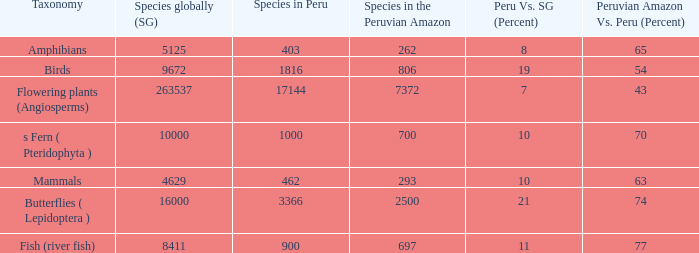Could you parse the entire table as a dict? {'header': ['Taxonomy', 'Species globally (SG)', 'Species in Peru', 'Species in the Peruvian Amazon', 'Peru Vs. SG (Percent)', 'Peruvian Amazon Vs. Peru (Percent)'], 'rows': [['Amphibians', '5125', '403', '262', '8', '65'], ['Birds', '9672', '1816', '806', '19', '54'], ['Flowering plants (Angiosperms)', '263537', '17144', '7372', '7', '43'], ['s Fern ( Pteridophyta )', '10000', '1000', '700', '10', '70'], ['Mammals', '4629', '462', '293', '10', '63'], ['Butterflies ( Lepidoptera )', '16000', '3366', '2500', '21', '74'], ['Fish (river fish)', '8411', '900', '697', '11', '77']]} What's the minimum species in the peruvian amazon with peru vs. world (percent) value of 7 7372.0. 